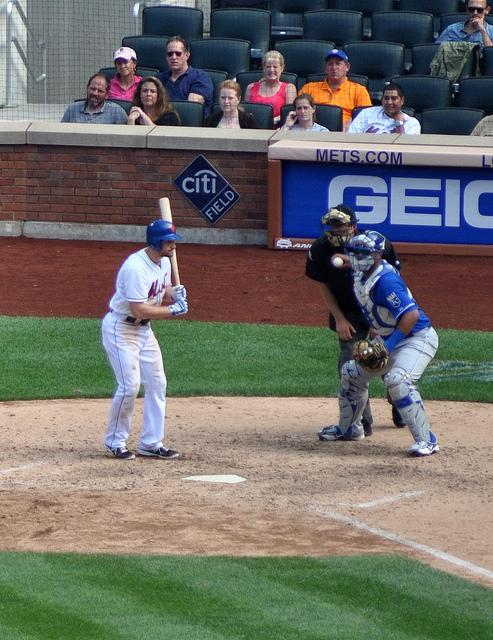Whose home field stadium is this?

Choices:
A) mariners
B) yankees
C) rockies
D) mets mets 